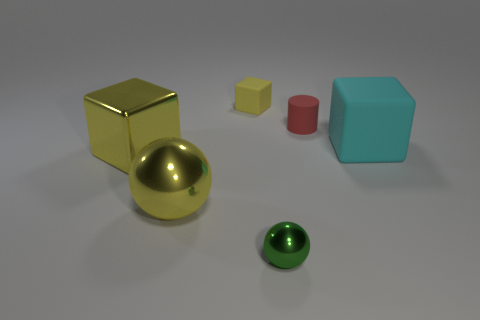Subtract all big yellow blocks. How many blocks are left? 2 Add 3 large purple matte spheres. How many objects exist? 9 Subtract all cyan blocks. How many blocks are left? 2 Subtract 1 yellow blocks. How many objects are left? 5 Subtract all balls. How many objects are left? 4 Subtract 1 blocks. How many blocks are left? 2 Subtract all blue cubes. Subtract all purple spheres. How many cubes are left? 3 Subtract all red balls. How many yellow cubes are left? 2 Subtract all small brown metal cylinders. Subtract all big yellow blocks. How many objects are left? 5 Add 4 large cyan matte blocks. How many large cyan matte blocks are left? 5 